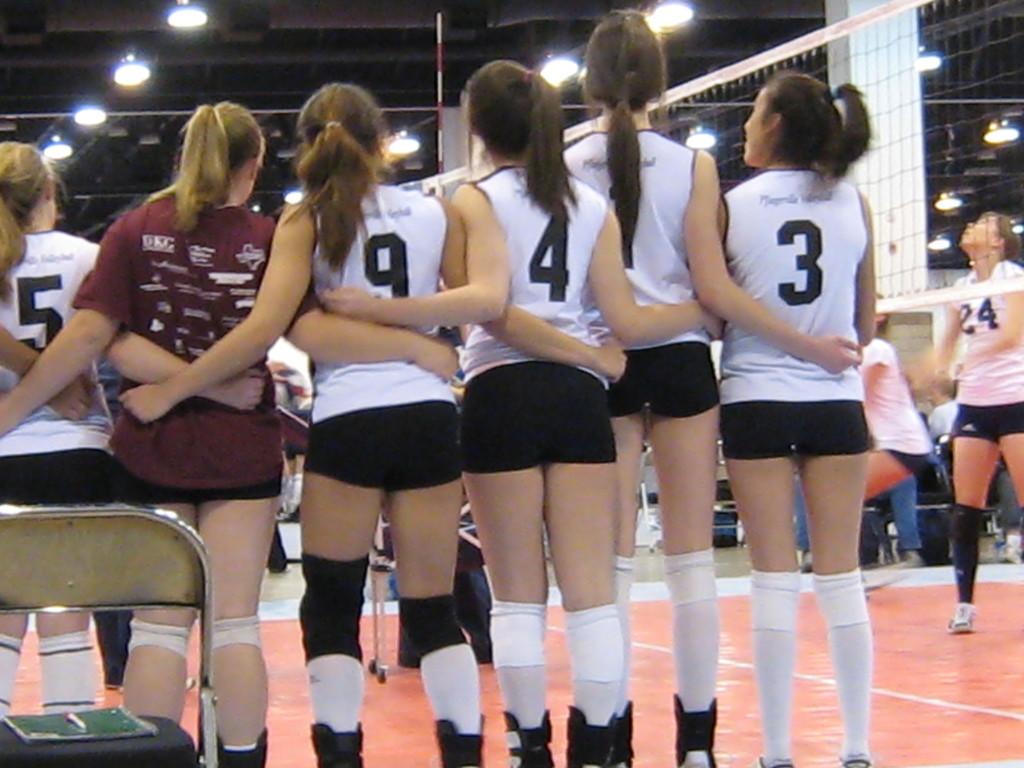What number is the girl on the right wearing?
Your answer should be very brief. 3. What is the number on the right of the red shirt?
Offer a terse response. 9. 